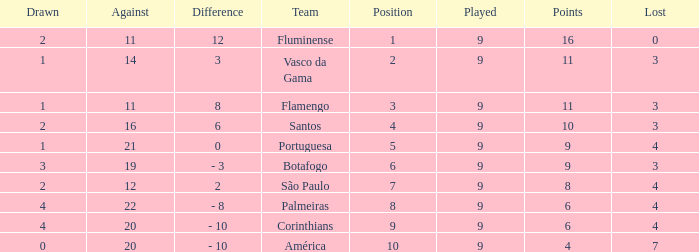Which Lost is the highest one that has a Drawn smaller than 4, and a Played smaller than 9? None. 